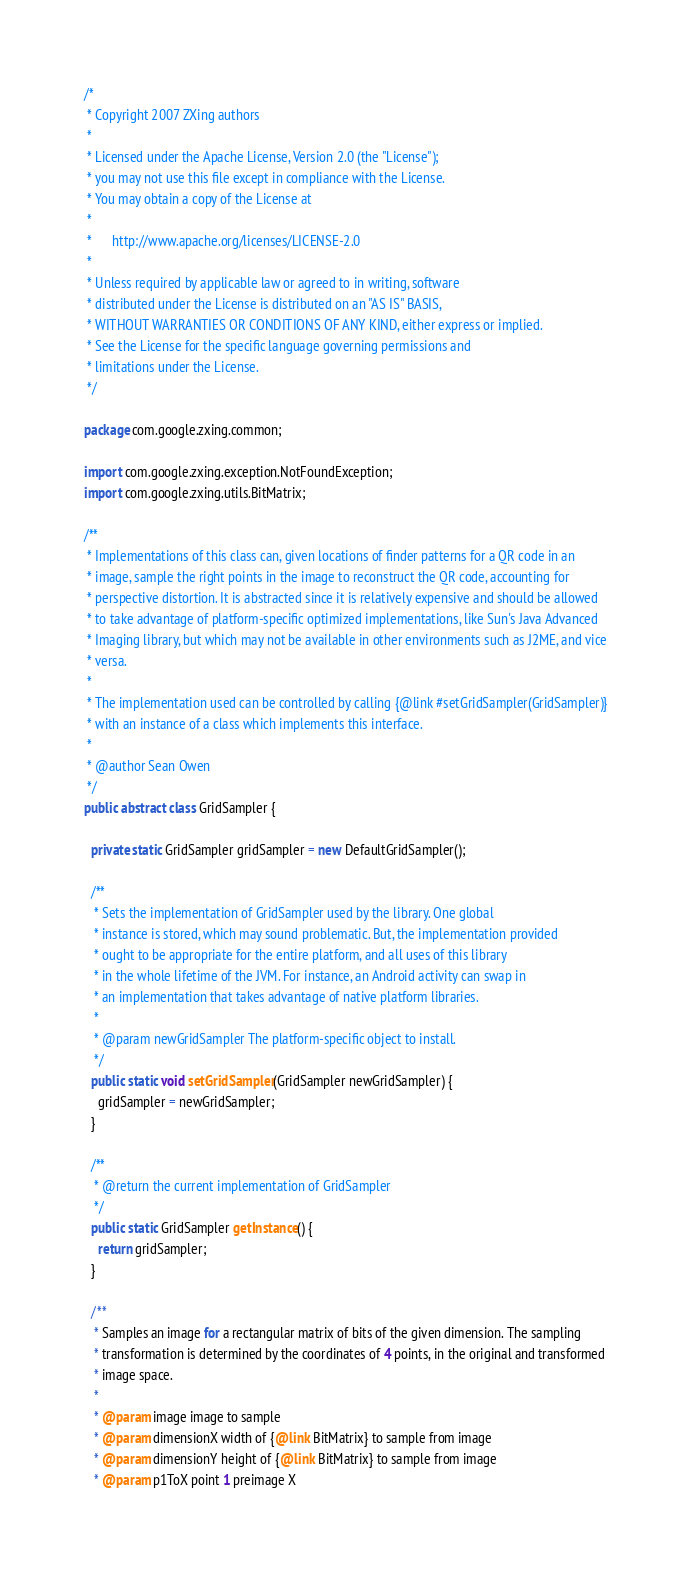Convert code to text. <code><loc_0><loc_0><loc_500><loc_500><_Java_>/*
 * Copyright 2007 ZXing authors
 *
 * Licensed under the Apache License, Version 2.0 (the "License");
 * you may not use this file except in compliance with the License.
 * You may obtain a copy of the License at
 *
 *      http://www.apache.org/licenses/LICENSE-2.0
 *
 * Unless required by applicable law or agreed to in writing, software
 * distributed under the License is distributed on an "AS IS" BASIS,
 * WITHOUT WARRANTIES OR CONDITIONS OF ANY KIND, either express or implied.
 * See the License for the specific language governing permissions and
 * limitations under the License.
 */

package com.google.zxing.common;

import com.google.zxing.exception.NotFoundException;
import com.google.zxing.utils.BitMatrix;

/**
 * Implementations of this class can, given locations of finder patterns for a QR code in an
 * image, sample the right points in the image to reconstruct the QR code, accounting for
 * perspective distortion. It is abstracted since it is relatively expensive and should be allowed
 * to take advantage of platform-specific optimized implementations, like Sun's Java Advanced
 * Imaging library, but which may not be available in other environments such as J2ME, and vice
 * versa.
 *
 * The implementation used can be controlled by calling {@link #setGridSampler(GridSampler)}
 * with an instance of a class which implements this interface.
 *
 * @author Sean Owen
 */
public abstract class GridSampler {

  private static GridSampler gridSampler = new DefaultGridSampler();

  /**
   * Sets the implementation of GridSampler used by the library. One global
   * instance is stored, which may sound problematic. But, the implementation provided
   * ought to be appropriate for the entire platform, and all uses of this library
   * in the whole lifetime of the JVM. For instance, an Android activity can swap in
   * an implementation that takes advantage of native platform libraries.
   *
   * @param newGridSampler The platform-specific object to install.
   */
  public static void setGridSampler(GridSampler newGridSampler) {
    gridSampler = newGridSampler;
  }

  /**
   * @return the current implementation of GridSampler
   */
  public static GridSampler getInstance() {
    return gridSampler;
  }

  /**
   * Samples an image for a rectangular matrix of bits of the given dimension. The sampling
   * transformation is determined by the coordinates of 4 points, in the original and transformed
   * image space.
   *
   * @param image image to sample
   * @param dimensionX width of {@link BitMatrix} to sample from image
   * @param dimensionY height of {@link BitMatrix} to sample from image
   * @param p1ToX point 1 preimage X</code> 